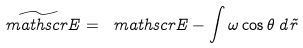Convert formula to latex. <formula><loc_0><loc_0><loc_500><loc_500>\widetilde { \ m a t h s c r { E } } = \ m a t h s c r { E } - \int \omega \cos \theta \, d \vec { r }</formula> 